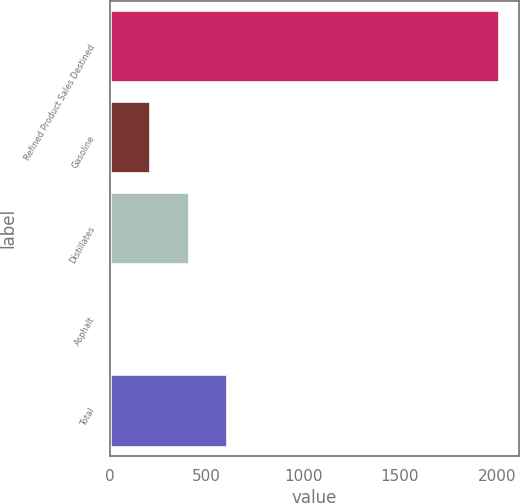Convert chart to OTSL. <chart><loc_0><loc_0><loc_500><loc_500><bar_chart><fcel>Refined Product Sales Destined<fcel>Gasoline<fcel>Distillates<fcel>Asphalt<fcel>Total<nl><fcel>2014<fcel>205.9<fcel>406.8<fcel>5<fcel>607.7<nl></chart> 